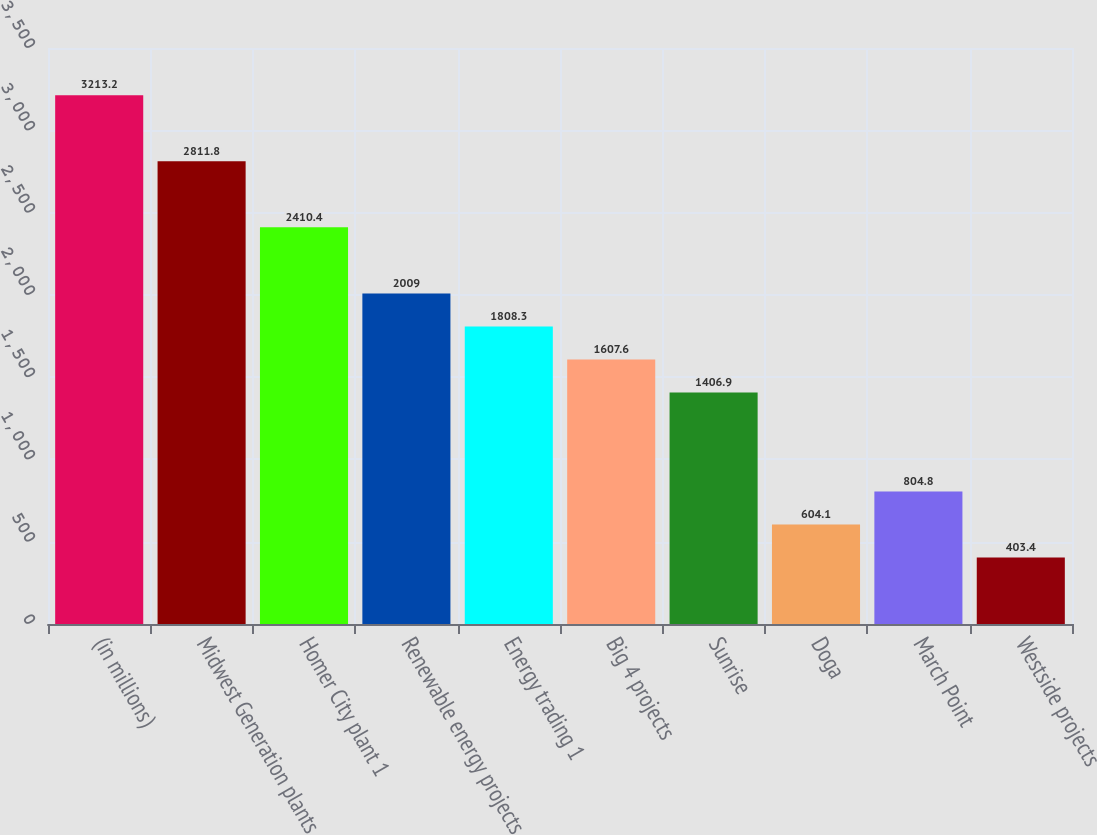Convert chart to OTSL. <chart><loc_0><loc_0><loc_500><loc_500><bar_chart><fcel>(in millions)<fcel>Midwest Generation plants<fcel>Homer City plant 1<fcel>Renewable energy projects<fcel>Energy trading 1<fcel>Big 4 projects<fcel>Sunrise<fcel>Doga<fcel>March Point<fcel>Westside projects<nl><fcel>3213.2<fcel>2811.8<fcel>2410.4<fcel>2009<fcel>1808.3<fcel>1607.6<fcel>1406.9<fcel>604.1<fcel>804.8<fcel>403.4<nl></chart> 